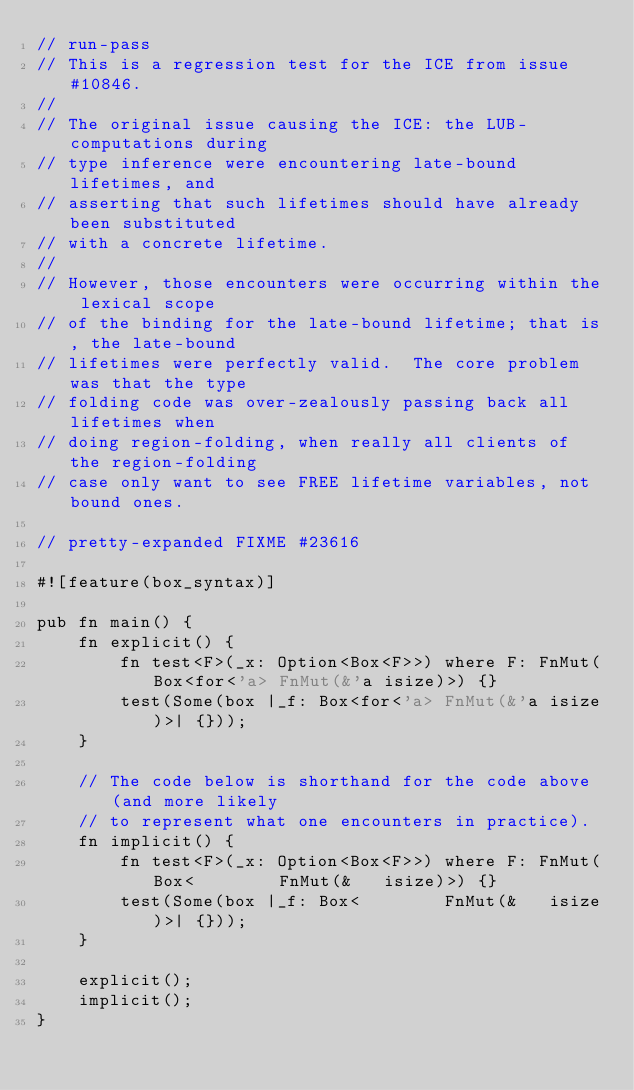<code> <loc_0><loc_0><loc_500><loc_500><_Rust_>// run-pass
// This is a regression test for the ICE from issue #10846.
//
// The original issue causing the ICE: the LUB-computations during
// type inference were encountering late-bound lifetimes, and
// asserting that such lifetimes should have already been substituted
// with a concrete lifetime.
//
// However, those encounters were occurring within the lexical scope
// of the binding for the late-bound lifetime; that is, the late-bound
// lifetimes were perfectly valid.  The core problem was that the type
// folding code was over-zealously passing back all lifetimes when
// doing region-folding, when really all clients of the region-folding
// case only want to see FREE lifetime variables, not bound ones.

// pretty-expanded FIXME #23616

#![feature(box_syntax)]

pub fn main() {
    fn explicit() {
        fn test<F>(_x: Option<Box<F>>) where F: FnMut(Box<for<'a> FnMut(&'a isize)>) {}
        test(Some(box |_f: Box<for<'a> FnMut(&'a isize)>| {}));
    }

    // The code below is shorthand for the code above (and more likely
    // to represent what one encounters in practice).
    fn implicit() {
        fn test<F>(_x: Option<Box<F>>) where F: FnMut(Box<        FnMut(&   isize)>) {}
        test(Some(box |_f: Box<        FnMut(&   isize)>| {}));
    }

    explicit();
    implicit();
}
</code> 